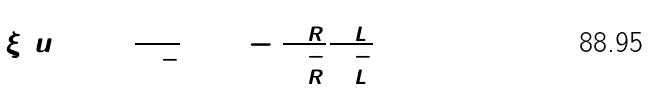Convert formula to latex. <formula><loc_0><loc_0><loc_500><loc_500>\xi ( u ) \colon = \frac { \Psi ^ { + } } { \Psi ^ { - } } = 1 - \frac { \Phi _ { R } ^ { + } } { \Phi _ { R } ^ { - } } \frac { \Phi _ { L } ^ { + } } { \Phi _ { L } ^ { - } }</formula> 